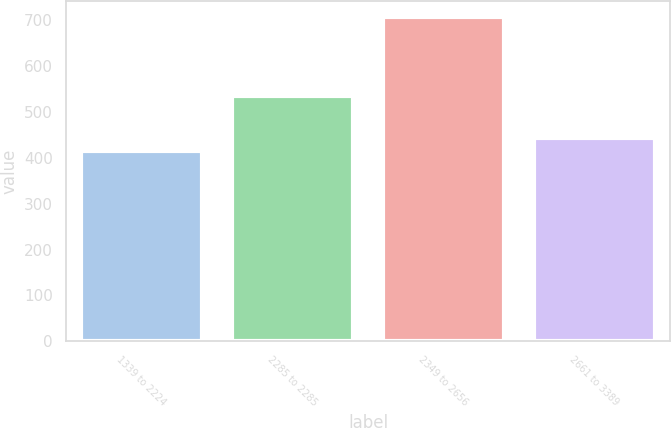<chart> <loc_0><loc_0><loc_500><loc_500><bar_chart><fcel>1339 to 2224<fcel>2285 to 2285<fcel>2349 to 2656<fcel>2661 to 3389<nl><fcel>414<fcel>535<fcel>706<fcel>443.2<nl></chart> 